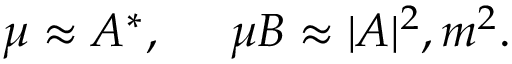<formula> <loc_0><loc_0><loc_500><loc_500>\mu \approx A ^ { * } , \, \mu B \approx | A | ^ { 2 } , m ^ { 2 } .</formula> 